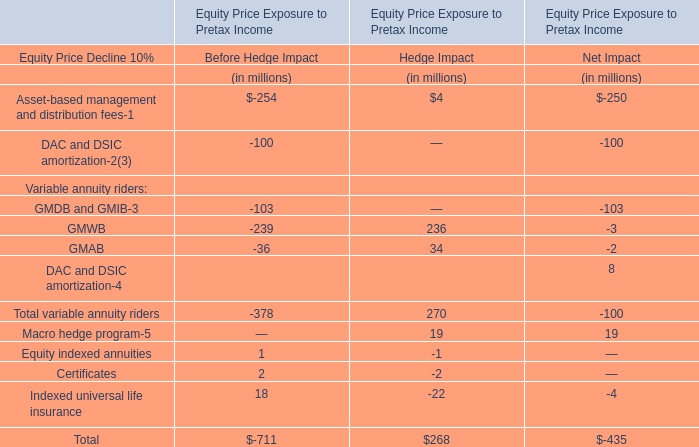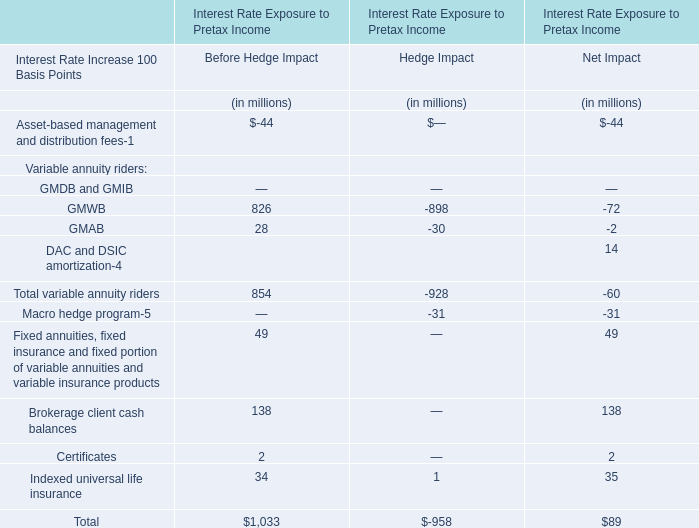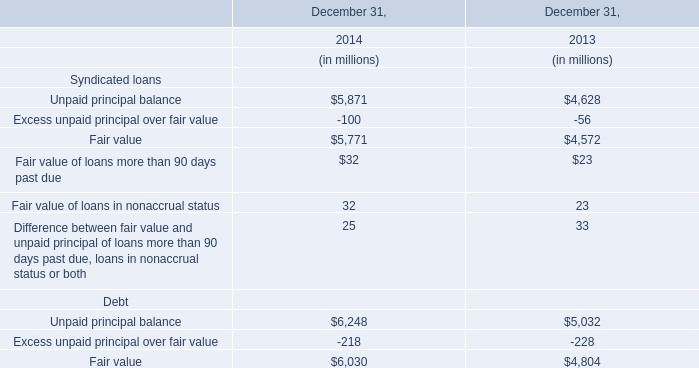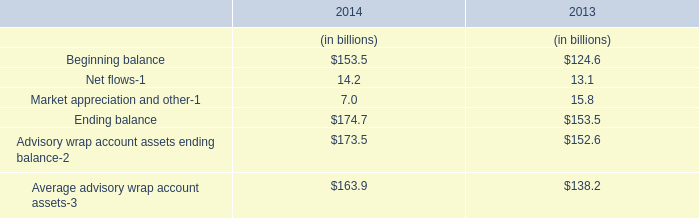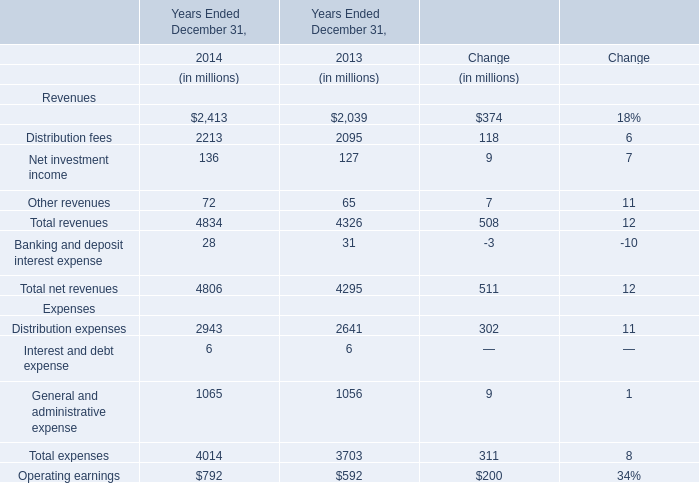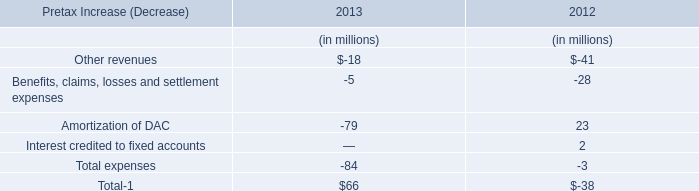Which year is Banking and deposit interest expense the lowest? 
Answer: 2014. 